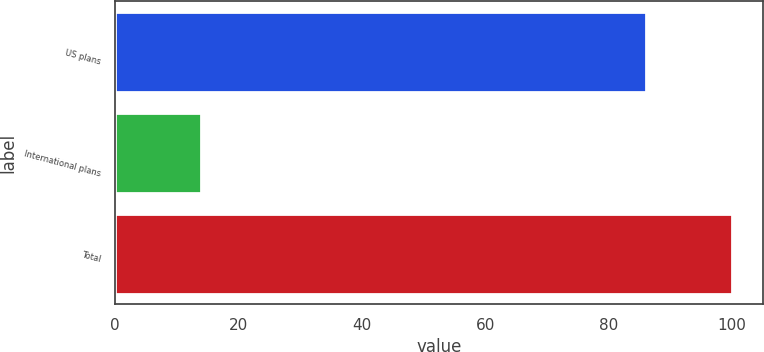Convert chart. <chart><loc_0><loc_0><loc_500><loc_500><bar_chart><fcel>US plans<fcel>International plans<fcel>Total<nl><fcel>86<fcel>14<fcel>100<nl></chart> 